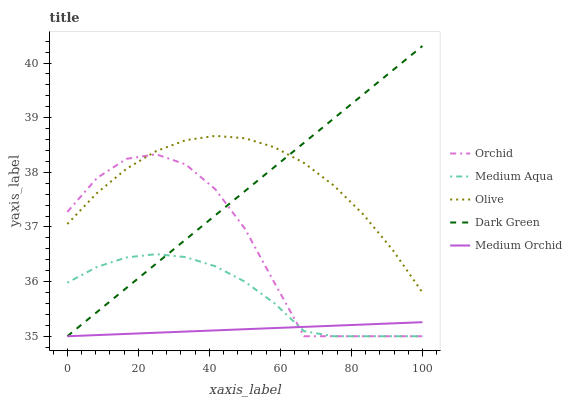Does Medium Orchid have the minimum area under the curve?
Answer yes or no. Yes. Does Olive have the maximum area under the curve?
Answer yes or no. Yes. Does Dark Green have the minimum area under the curve?
Answer yes or no. No. Does Dark Green have the maximum area under the curve?
Answer yes or no. No. Is Dark Green the smoothest?
Answer yes or no. Yes. Is Orchid the roughest?
Answer yes or no. Yes. Is Medium Orchid the smoothest?
Answer yes or no. No. Is Medium Orchid the roughest?
Answer yes or no. No. Does Dark Green have the highest value?
Answer yes or no. Yes. Does Medium Orchid have the highest value?
Answer yes or no. No. Is Medium Aqua less than Olive?
Answer yes or no. Yes. Is Olive greater than Medium Orchid?
Answer yes or no. Yes. Does Medium Orchid intersect Dark Green?
Answer yes or no. Yes. Is Medium Orchid less than Dark Green?
Answer yes or no. No. Is Medium Orchid greater than Dark Green?
Answer yes or no. No. Does Medium Aqua intersect Olive?
Answer yes or no. No. 